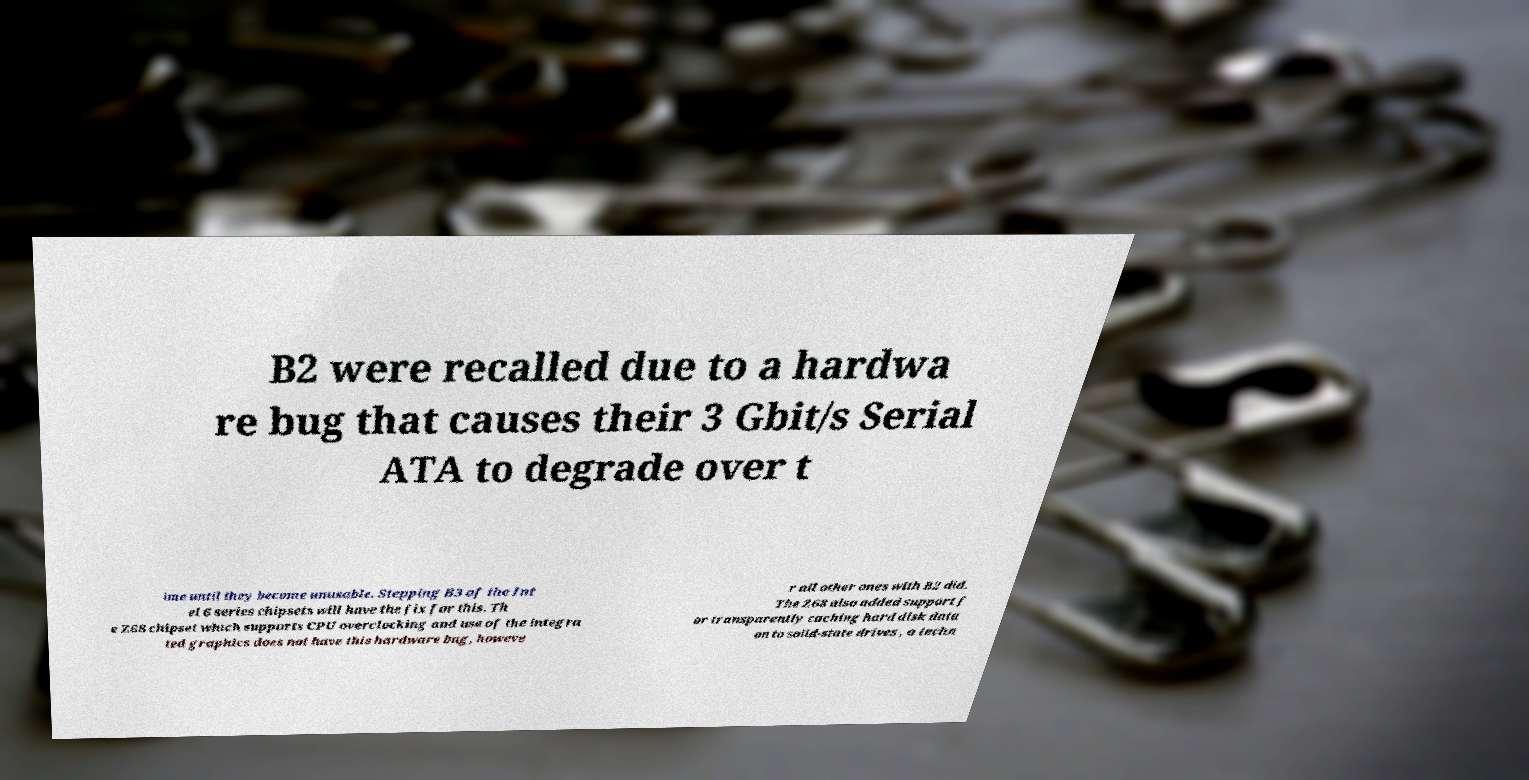I need the written content from this picture converted into text. Can you do that? B2 were recalled due to a hardwa re bug that causes their 3 Gbit/s Serial ATA to degrade over t ime until they become unusable. Stepping B3 of the Int el 6 series chipsets will have the fix for this. Th e Z68 chipset which supports CPU overclocking and use of the integra ted graphics does not have this hardware bug, howeve r all other ones with B2 did. The Z68 also added support f or transparently caching hard disk data on to solid-state drives , a techn 